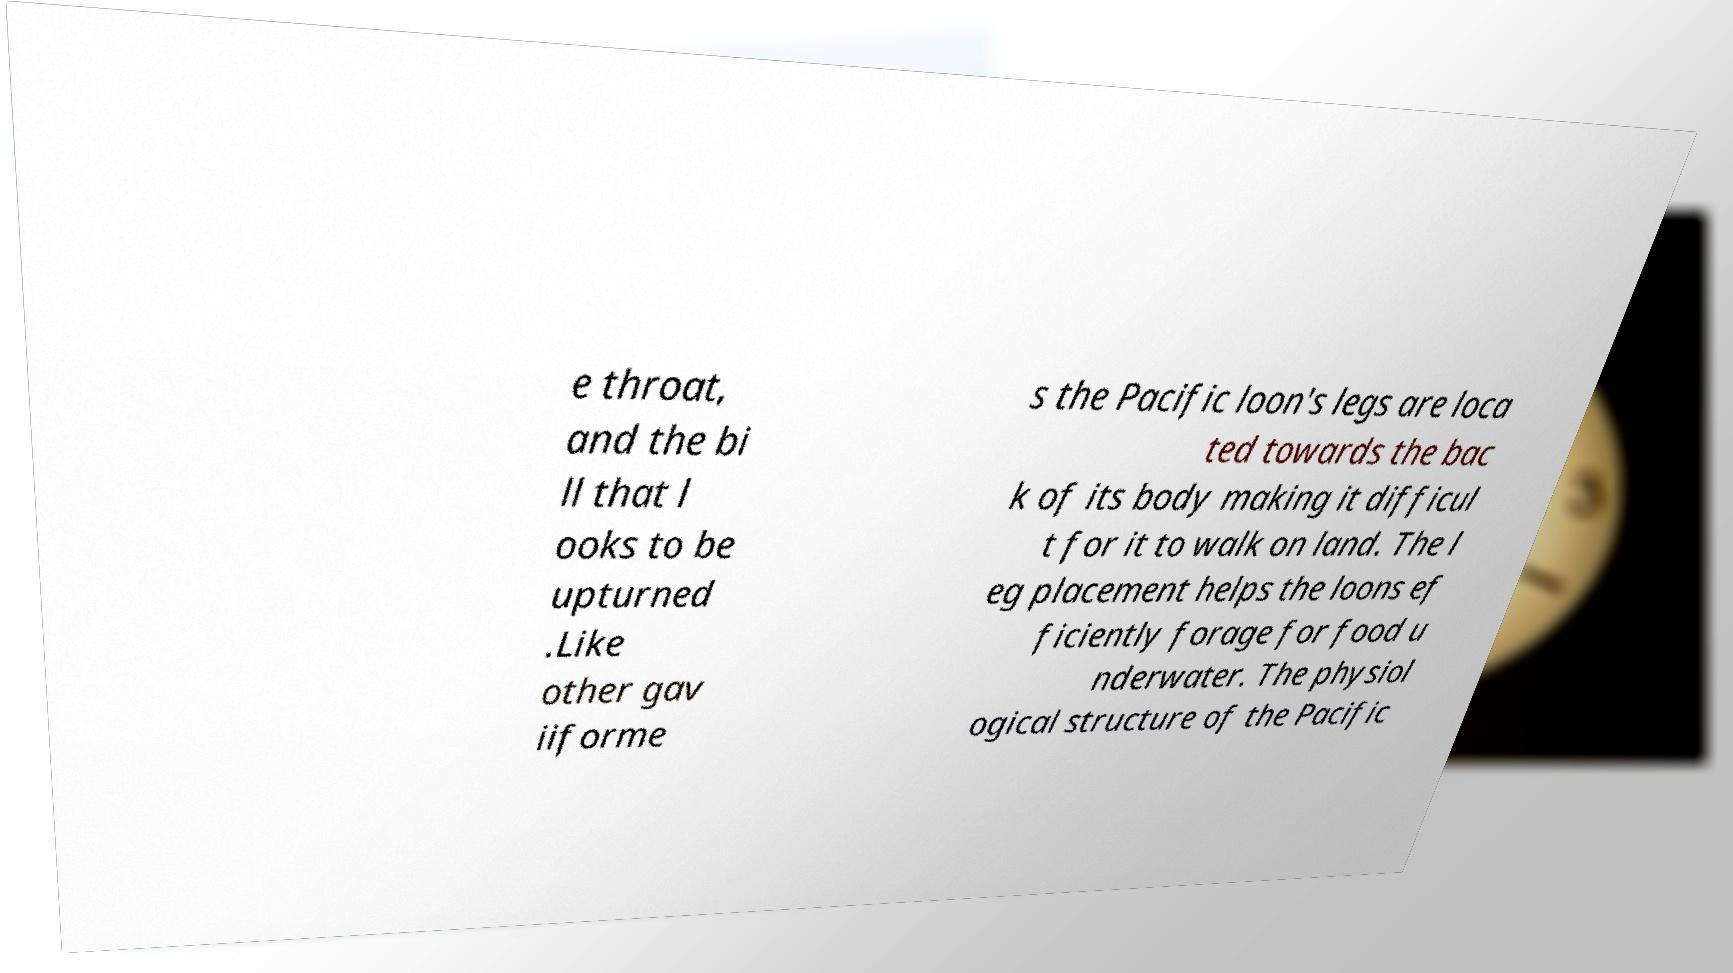Can you accurately transcribe the text from the provided image for me? e throat, and the bi ll that l ooks to be upturned .Like other gav iiforme s the Pacific loon's legs are loca ted towards the bac k of its body making it difficul t for it to walk on land. The l eg placement helps the loons ef ficiently forage for food u nderwater. The physiol ogical structure of the Pacific 